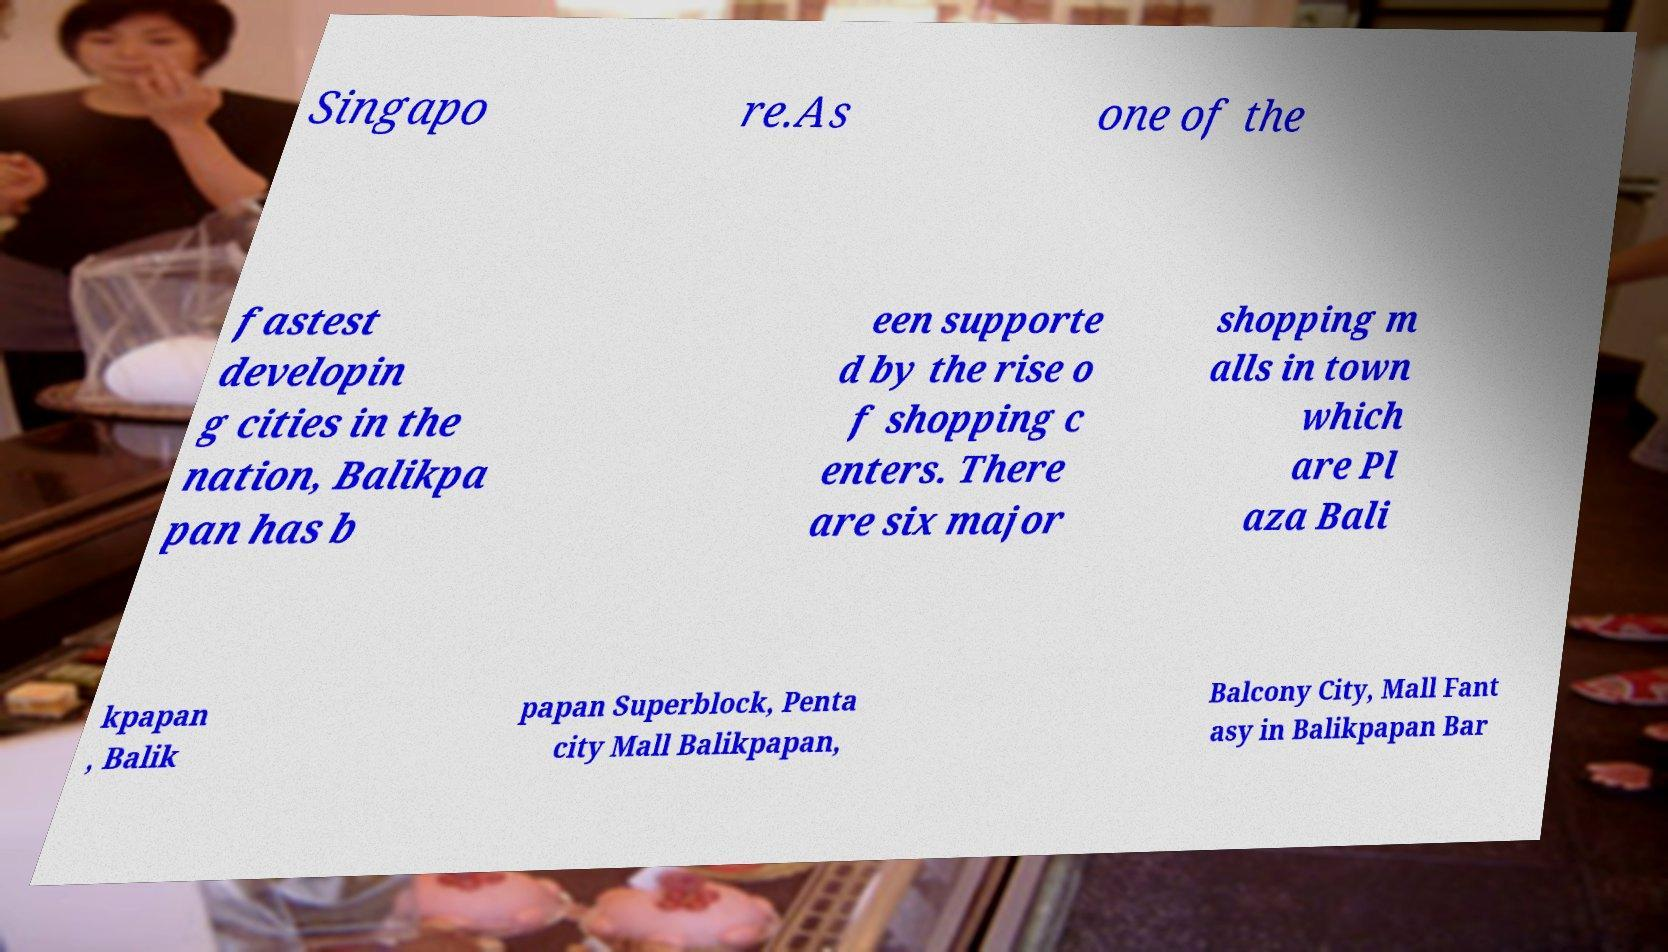For documentation purposes, I need the text within this image transcribed. Could you provide that? Singapo re.As one of the fastest developin g cities in the nation, Balikpa pan has b een supporte d by the rise o f shopping c enters. There are six major shopping m alls in town which are Pl aza Bali kpapan , Balik papan Superblock, Penta city Mall Balikpapan, Balcony City, Mall Fant asy in Balikpapan Bar 